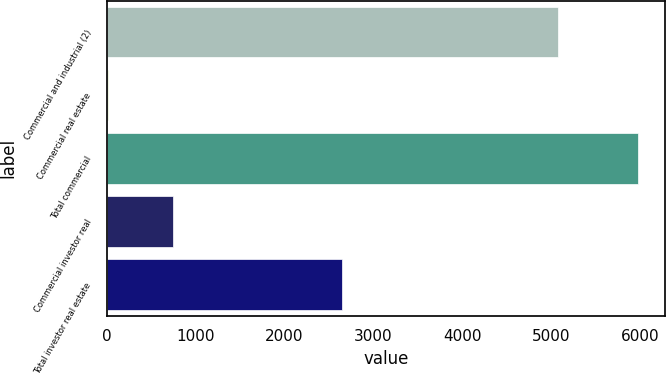<chart> <loc_0><loc_0><loc_500><loc_500><bar_chart><fcel>Commercial and industrial (2)<fcel>Commercial real estate<fcel>Total commercial<fcel>Commercial investor real<fcel>Total investor real estate<nl><fcel>5070<fcel>16<fcel>5978<fcel>750<fcel>2650<nl></chart> 